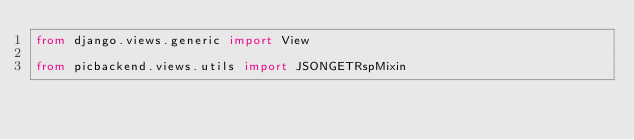Convert code to text. <code><loc_0><loc_0><loc_500><loc_500><_Python_>from django.views.generic import View

from picbackend.views.utils import JSONGETRspMixin</code> 